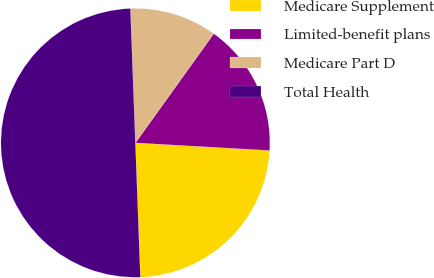Convert chart to OTSL. <chart><loc_0><loc_0><loc_500><loc_500><pie_chart><fcel>Medicare Supplement<fcel>Limited-benefit plans<fcel>Medicare Part D<fcel>Total Health<nl><fcel>23.5%<fcel>16.0%<fcel>10.5%<fcel>50.0%<nl></chart> 